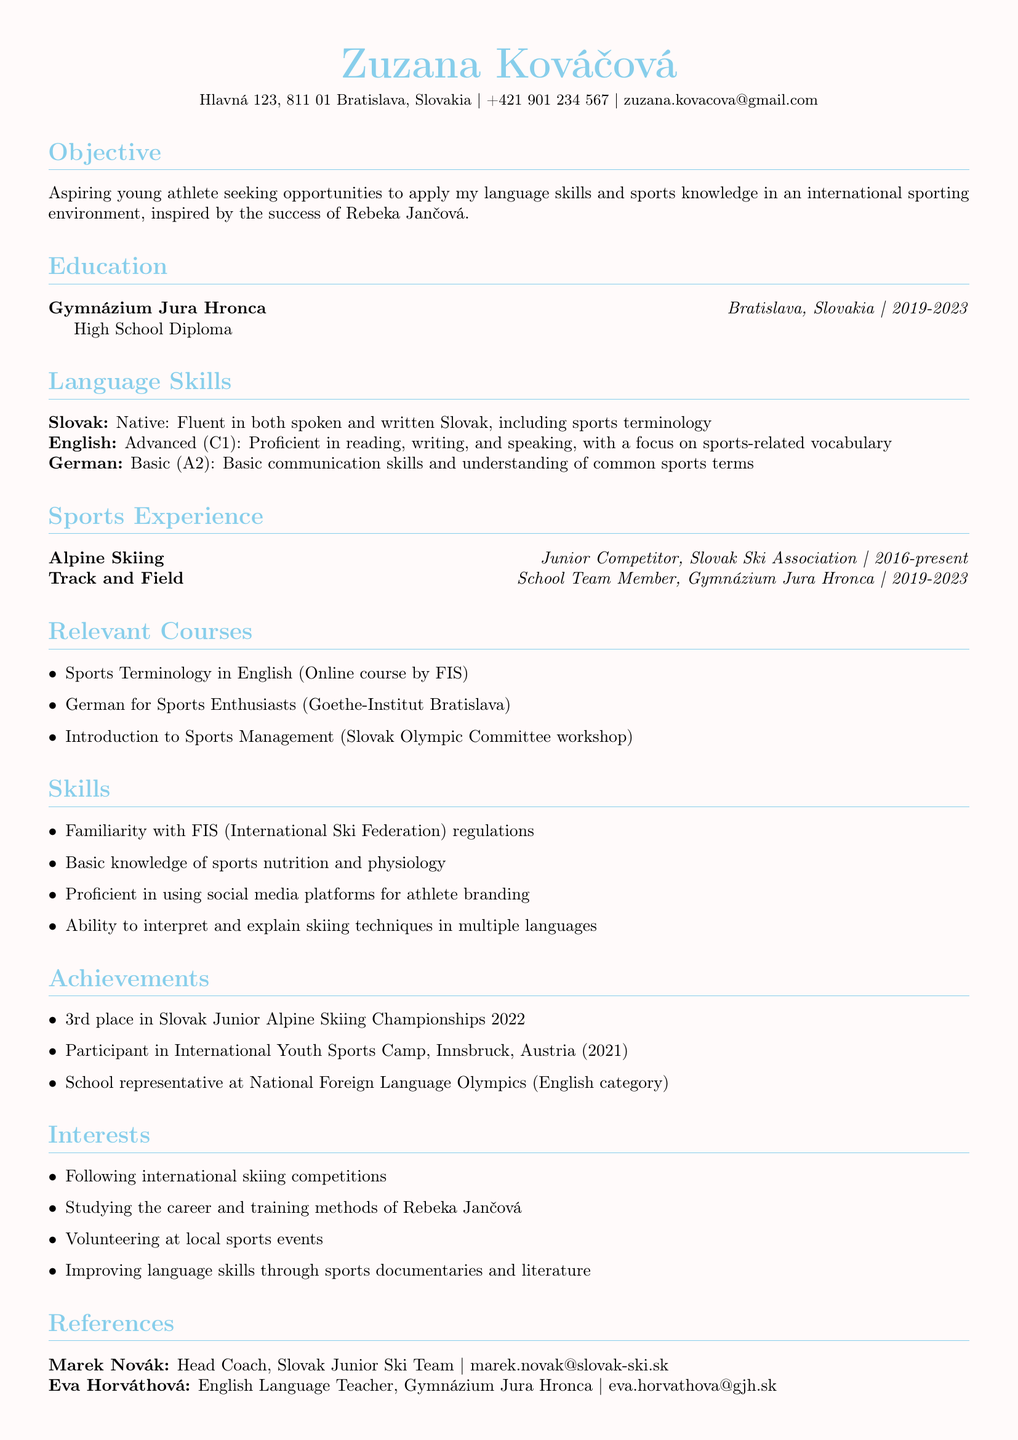What is Zuzana's age? Zuzana's age is clearly indicated in the personal information section of the document.
Answer: 18 What is Zuzana's email address? The email address is provided in the personal information section of the document.
Answer: zuzana.kovacova@gmail.com What sports experience does Zuzana have? The document lists her participation in sports under the sports experience section, specifically mentioning two sports.
Answer: Alpine Skiing, Track and Field What is Zuzana's language skill level in English? The document specifies the proficiency level in English language skills in the language skills section.
Answer: Advanced (C1) Where did Zuzana complete her high school education? The education section of the document clearly states the institution where Zuzana completed her high school education.
Answer: Gymnázium Jura Hronca What achievement is mentioned first in Zuzana's CV? The achievements section lists notable accomplishments, with the first listed achievement being highlighted.
Answer: 3rd place in Slovak Junior Alpine Skiing Championships 2022 Which organization did Zuzana compete with in Alpine Skiing? The sports experience section mentions the organization that Zuzana competes with in her sport.
Answer: Slovak Ski Association What key interest is Zuzana pursuing related to Rebeka Jančová? Zuzana's interests include specific activities related to her idol, as stated in the interests section of the document.
Answer: Studying the career and training methods of Rebeka Jančová What relevant course did Zuzana take about sports terminology in English? The relevant courses section of the document includes this specific course that pertains to sports terminology.
Answer: Sports Terminology in English 